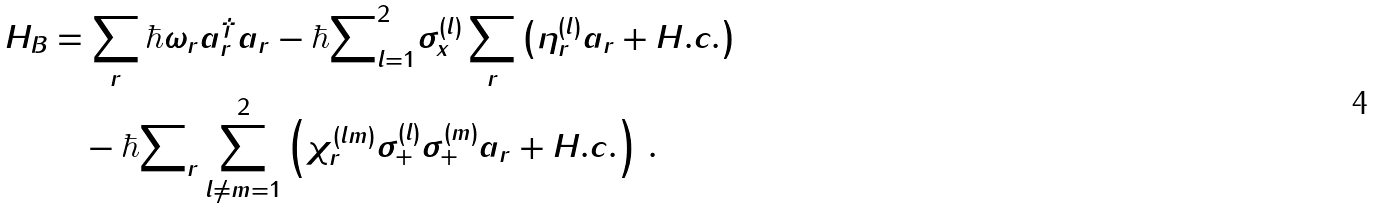Convert formula to latex. <formula><loc_0><loc_0><loc_500><loc_500>H _ { B } & = \sum _ { r } \hbar { \omega } _ { r } a ^ { \dag } _ { r } a _ { r } - \hbar { \sum } _ { l = 1 } ^ { 2 } \sigma _ { x } ^ { ( l ) } \sum _ { r } \left ( \eta _ { r } ^ { ( l ) } a _ { r } + H . c . \right ) \\ & \quad - \hbar { \sum } _ { r } \sum _ { l \neq m = 1 } ^ { 2 } \left ( \chi _ { r } ^ { ( l m ) } \sigma _ { + } ^ { ( l ) } \sigma _ { + } ^ { ( m ) } a _ { r } + H . c . \right ) \, .</formula> 